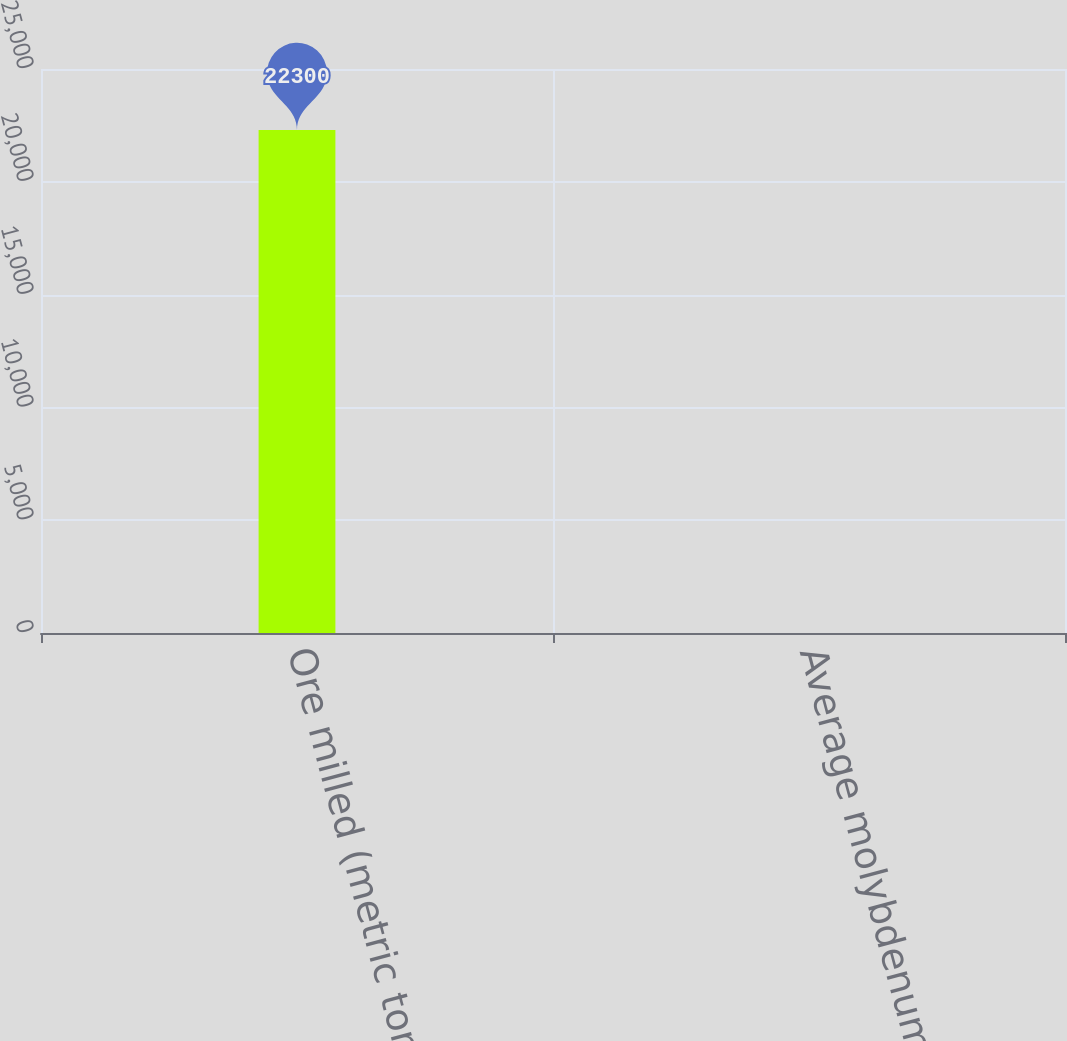Convert chart to OTSL. <chart><loc_0><loc_0><loc_500><loc_500><bar_chart><fcel>Ore milled (metric tons per<fcel>Average molybdenum ore grade<nl><fcel>22300<fcel>0.24<nl></chart> 